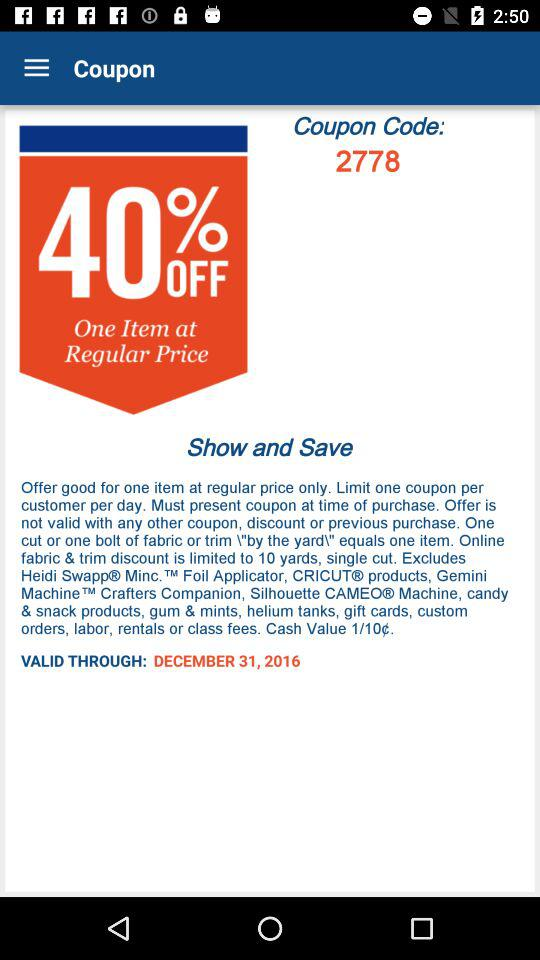How much is the discount?
Answer the question using a single word or phrase. 40% 